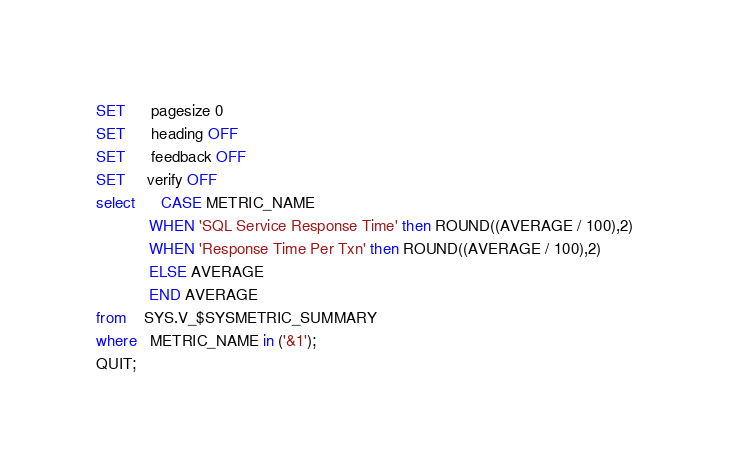Convert code to text. <code><loc_0><loc_0><loc_500><loc_500><_SQL_>SET      pagesize 0
SET      heading OFF
SET      feedback OFF
SET	 verify OFF
select      CASE METRIC_NAME
            WHEN 'SQL Service Response Time' then ROUND((AVERAGE / 100),2)
            WHEN 'Response Time Per Txn' then ROUND((AVERAGE / 100),2)
            ELSE AVERAGE
            END AVERAGE
from    SYS.V_$SYSMETRIC_SUMMARY 
where   METRIC_NAME in ('&1');
QUIT;
</code> 